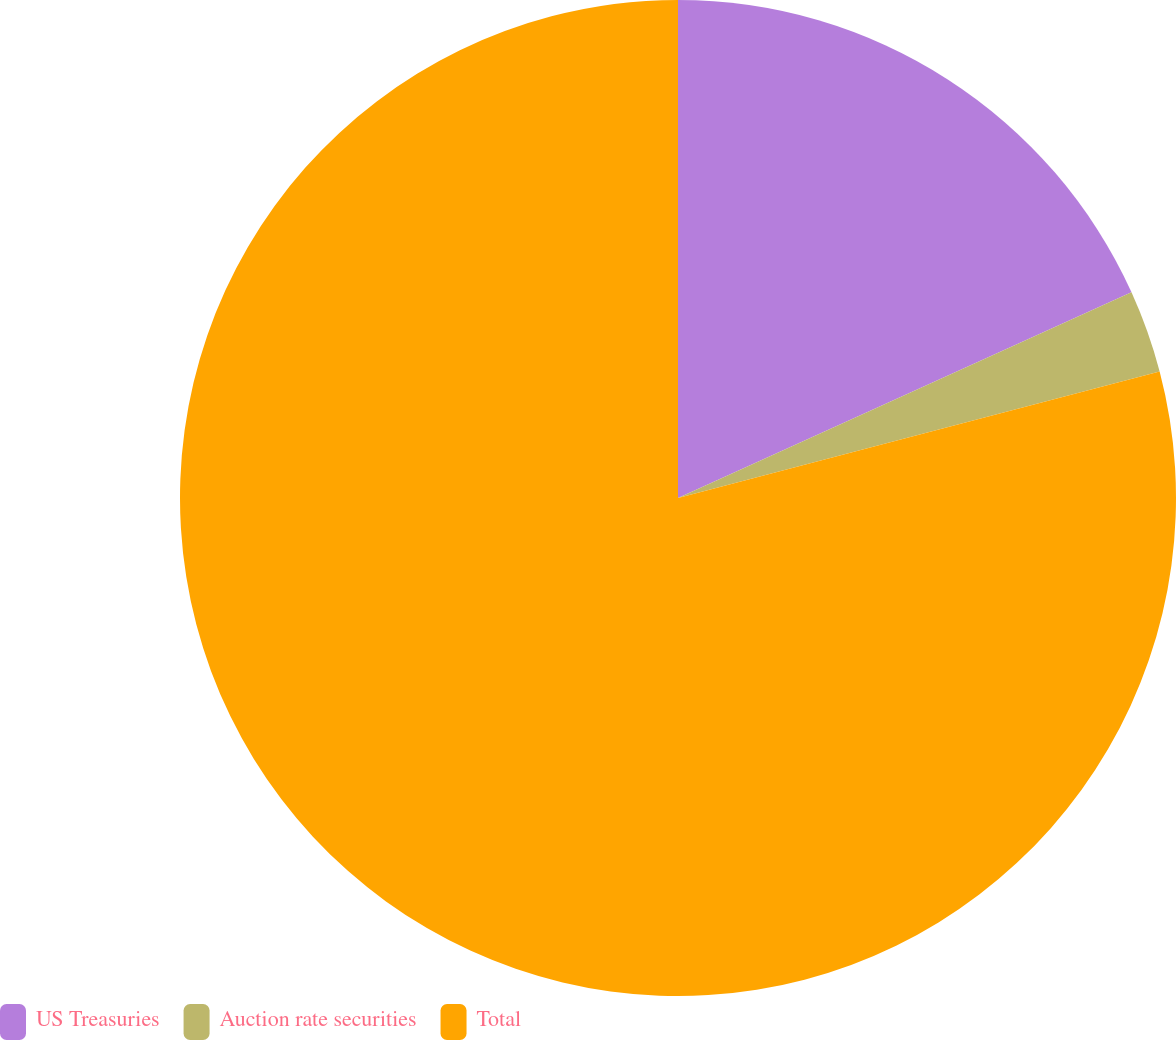Convert chart to OTSL. <chart><loc_0><loc_0><loc_500><loc_500><pie_chart><fcel>US Treasuries<fcel>Auction rate securities<fcel>Total<nl><fcel>18.22%<fcel>2.69%<fcel>79.09%<nl></chart> 